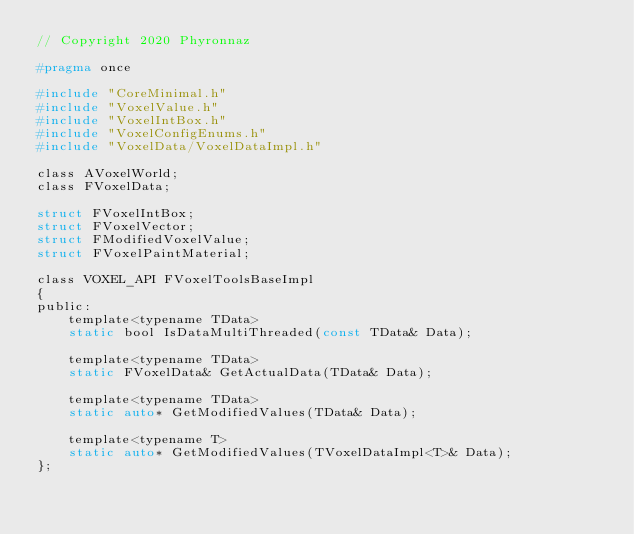<code> <loc_0><loc_0><loc_500><loc_500><_C_>// Copyright 2020 Phyronnaz

#pragma once

#include "CoreMinimal.h"
#include "VoxelValue.h"
#include "VoxelIntBox.h"
#include "VoxelConfigEnums.h"
#include "VoxelData/VoxelDataImpl.h"

class AVoxelWorld;
class FVoxelData;

struct FVoxelIntBox;
struct FVoxelVector;
struct FModifiedVoxelValue;
struct FVoxelPaintMaterial;

class VOXEL_API FVoxelToolsBaseImpl
{
public:
	template<typename TData>
	static bool IsDataMultiThreaded(const TData& Data);
	
	template<typename TData>
	static FVoxelData& GetActualData(TData& Data);
	
	template<typename TData>
	static auto* GetModifiedValues(TData& Data);
	
	template<typename T>
	static auto* GetModifiedValues(TVoxelDataImpl<T>& Data);
};</code> 